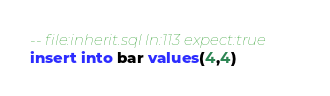<code> <loc_0><loc_0><loc_500><loc_500><_SQL_>-- file:inherit.sql ln:113 expect:true
insert into bar values(4,4)
</code> 